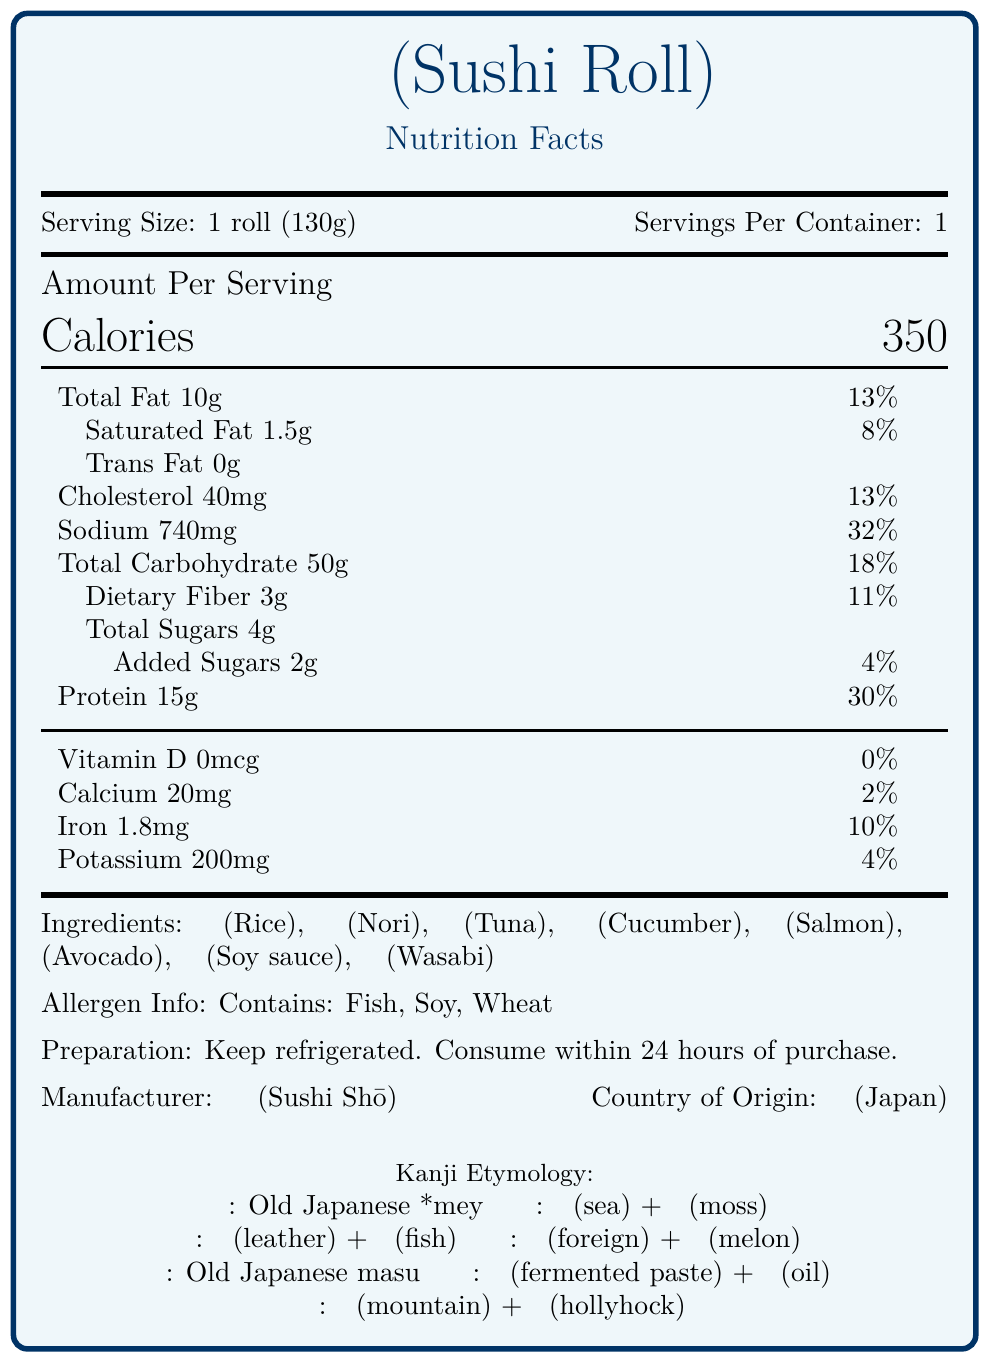what is the serving size of the sushi roll? The serving size is clearly stated at the beginning of the document as "1 roll (130g)".
Answer: 1 roll (130g) how many calories are in one serving of the sushi roll? The calories per serving are given prominently in the section labeled "Amount Per Serving".
Answer: 350 what is the daily value percentage of sodium in one roll? The sodium amount and its daily value percentage are listed as "Sodium: 740mg, 32%" in the nutrition details.
Answer: 32% List the ingredients of the sushi roll in kanji. These are listed under the "Ingredients" section.
Answer: 米, 海苔, 鮪, 胡瓜, 鱒, アボカド, 醤油, 山葵 Name one ingredient in the sushi roll whose etymology includes a compound word in kanji. The etymology of "海苔 (Nori)" is "Compound of 海 (umi, 'sea') + 苔 (koke, 'moss')".
Answer: 海苔 (Nori) which vitamin is completely absent in the sushi roll? A. Vitamin D B. Calcium C. Iron D. Potassium The vitamin amounts are listed, and Vitamin D has "0mcg", indicating its absence.
Answer: A. Vitamin D which of these ingredients does the sushi roll contain? A. Tofu B. Chicken C. Tuna D. Pork The ingredients section lists "鮪 (Tuna)" indicating its presence in the sushi roll.
Answer: C. Tuna Is the Sushi Roll a good source of protein? With 15g of protein making up 30% of the daily value, it's considered a good source of protein.
Answer: Yes Does the product contain added sugars? Under "Total Sugars", it mentions "Added Sugars 2g".
Answer: Yes, 2g Summarize the main nutritional information of the sushi roll. The document details the nutritional breakdown, ingredients, allergen information, and preparation instructions for the sushi roll.
Answer: The sushi roll, with a serving size of 130g, contains 350 calories and key nutrients including 10g of total fat, 50g of carbohydrates, and 15g of protein. It provides a significant amount of sodium (740mg, 32% DV), but lacks Vitamin D. The ingredients are typical sushi components like rice, nori, and fish, with some avocado and soy sauce. It contains fish, soy, and wheat allergens. The product is from Japan and should be consumed within 24 hours if refrigerated. Which ingredient's kanji etymology mentions "mountain"? The etymology for "山葵 (Wasabi)" includes "山 (yama, 'mountain')".
Answer: 山葵 (Wasabi) How is the preparation of the sushi roll instructed? This is directly stated under the "Preparation" section in the document.
Answer: Keep refrigerated. Consume within 24 hours of purchase. How much iron is in one serving? The amount of iron per serving is listed as "Iron 1.8mg" under vitamins and minerals.
Answer: 1.8mg what is the origin of the word 'avocado' used for one of the ingredients in the sushi roll? This etymology is provided under the explanation for "アボカド (Avocado)".
Answer: Loanword from English 'avocado', ultimately from Nahuatl āhuacatl what allergens are present in the sushi roll? The allergen information states "Contains: Fish, Soy, Wheat".
Answer: Fish, Soy, Wheat what is the sodium content in one serving of the sushi roll? The sodium content is listed explicitly next to its daily value percentage as "740mg".
Answer: 740mg how should the sushi roll be stored before consumption? The preparation instructions specify that the product should be kept refrigerated.
Answer: Keep refrigerated. How many grams of dietary fiber are in one serving? The dietary fiber content is clearly listed under the "Total Carbohydrate" breakdown as "Dietary Fiber 3g".
Answer: 3g What is the daily value percentage of total fat in one serving? A. 8% B. 13% C. 30% D. 18% The total fat daily value is given as 13% next to "Total Fat 10g".
Answer: B. 13% Who is the manufacturer of the sushi roll? The document lists the manufacturer as "寿司匠 (Sushi Shō)" under the details section.
Answer: 寿司匠 (Sushi Shō) Does the document indicate if the sushi roll contains any animal products other than fish? The document does not specify the inclusion of any other animal products beyond fish.
Answer: Not enough information 